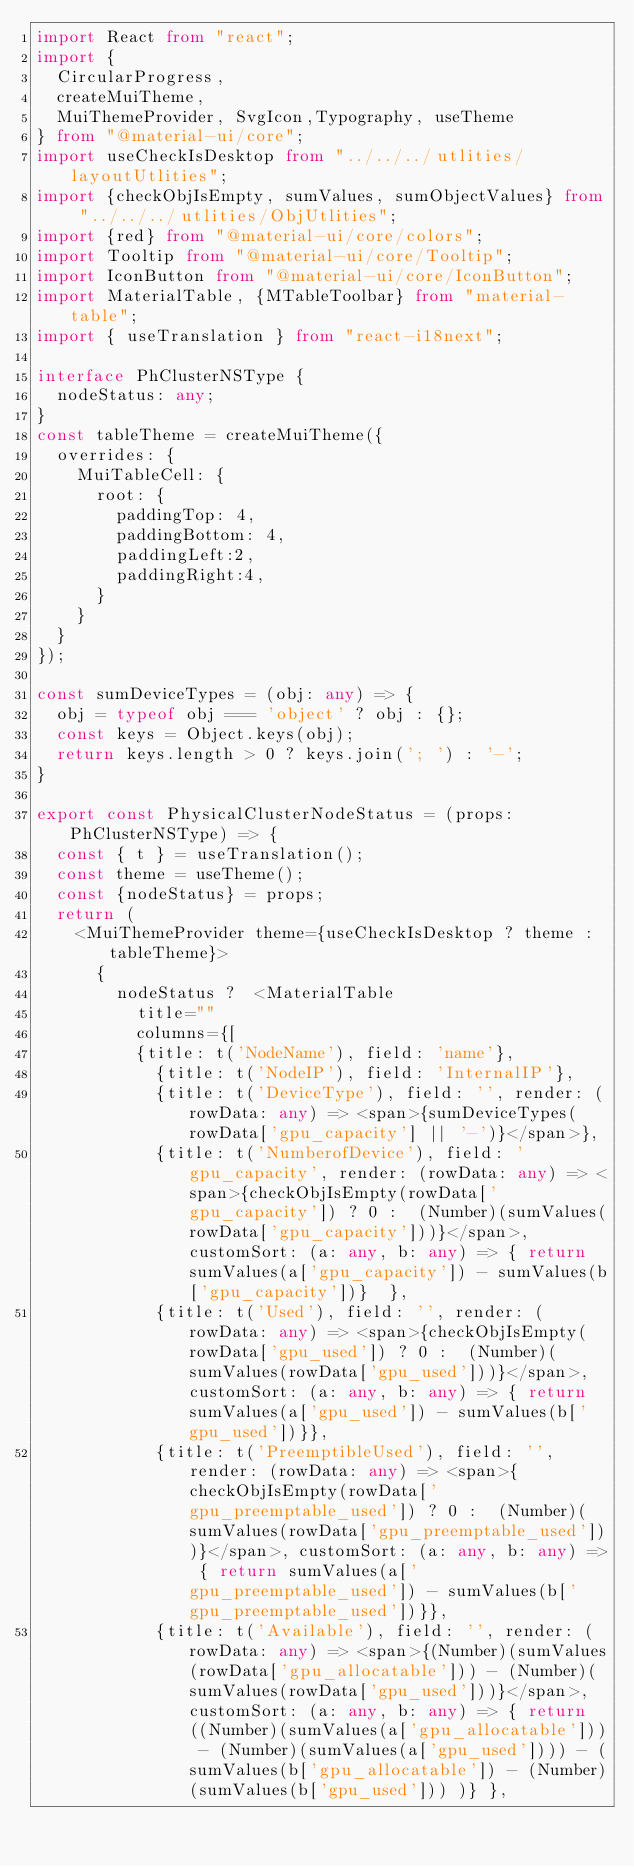<code> <loc_0><loc_0><loc_500><loc_500><_TypeScript_>import React from "react";
import {
  CircularProgress,
  createMuiTheme,
  MuiThemeProvider, SvgIcon,Typography, useTheme
} from "@material-ui/core";
import useCheckIsDesktop from "../../../utlities/layoutUtlities";
import {checkObjIsEmpty, sumValues, sumObjectValues} from "../../../utlities/ObjUtlities";
import {red} from "@material-ui/core/colors";
import Tooltip from "@material-ui/core/Tooltip";
import IconButton from "@material-ui/core/IconButton";
import MaterialTable, {MTableToolbar} from "material-table";
import { useTranslation } from "react-i18next";

interface PhClusterNSType {
  nodeStatus: any;
}
const tableTheme = createMuiTheme({
  overrides: {
    MuiTableCell: {
      root: {
        paddingTop: 4,
        paddingBottom: 4,
        paddingLeft:2,
        paddingRight:4,
      }
    }
  }
});

const sumDeviceTypes = (obj: any) => {
  obj = typeof obj === 'object' ? obj : {};
  const keys = Object.keys(obj);
  return keys.length > 0 ? keys.join('; ') : '-';
}

export const PhysicalClusterNodeStatus = (props: PhClusterNSType) => {
  const { t } = useTranslation();
  const theme = useTheme();
  const {nodeStatus} = props;
  return (
    <MuiThemeProvider theme={useCheckIsDesktop ? theme : tableTheme}>
      {
        nodeStatus ?  <MaterialTable
          title=""
          columns={[
          {title: t('NodeName'), field: 'name'},
            {title: t('NodeIP'), field: 'InternalIP'},
            {title: t('DeviceType'), field: '', render: (rowData: any) => <span>{sumDeviceTypes(rowData['gpu_capacity'] || '-')}</span>},
            {title: t('NumberofDevice'), field: 'gpu_capacity', render: (rowData: any) => <span>{checkObjIsEmpty(rowData['gpu_capacity']) ? 0 :  (Number)(sumValues(rowData['gpu_capacity']))}</span>, customSort: (a: any, b: any) => { return sumValues(a['gpu_capacity']) - sumValues(b['gpu_capacity'])}  },
            {title: t('Used'), field: '', render: (rowData: any) => <span>{checkObjIsEmpty(rowData['gpu_used']) ? 0 :  (Number)(sumValues(rowData['gpu_used']))}</span>, customSort: (a: any, b: any) => { return sumValues(a['gpu_used']) - sumValues(b['gpu_used'])}},
            {title: t('PreemptibleUsed'), field: '', render: (rowData: any) => <span>{checkObjIsEmpty(rowData['gpu_preemptable_used']) ? 0 :  (Number)(sumValues(rowData['gpu_preemptable_used']))}</span>, customSort: (a: any, b: any) => { return sumValues(a['gpu_preemptable_used']) - sumValues(b['gpu_preemptable_used'])}},
            {title: t('Available'), field: '', render: (rowData: any) => <span>{(Number)(sumValues(rowData['gpu_allocatable'])) - (Number)(sumValues(rowData['gpu_used']))}</span>, customSort: (a: any, b: any) => { return ((Number)(sumValues(a['gpu_allocatable'])) - (Number)(sumValues(a['gpu_used']))) - (sumValues(b['gpu_allocatable']) - (Number)(sumValues(b['gpu_used'])) )} },</code> 